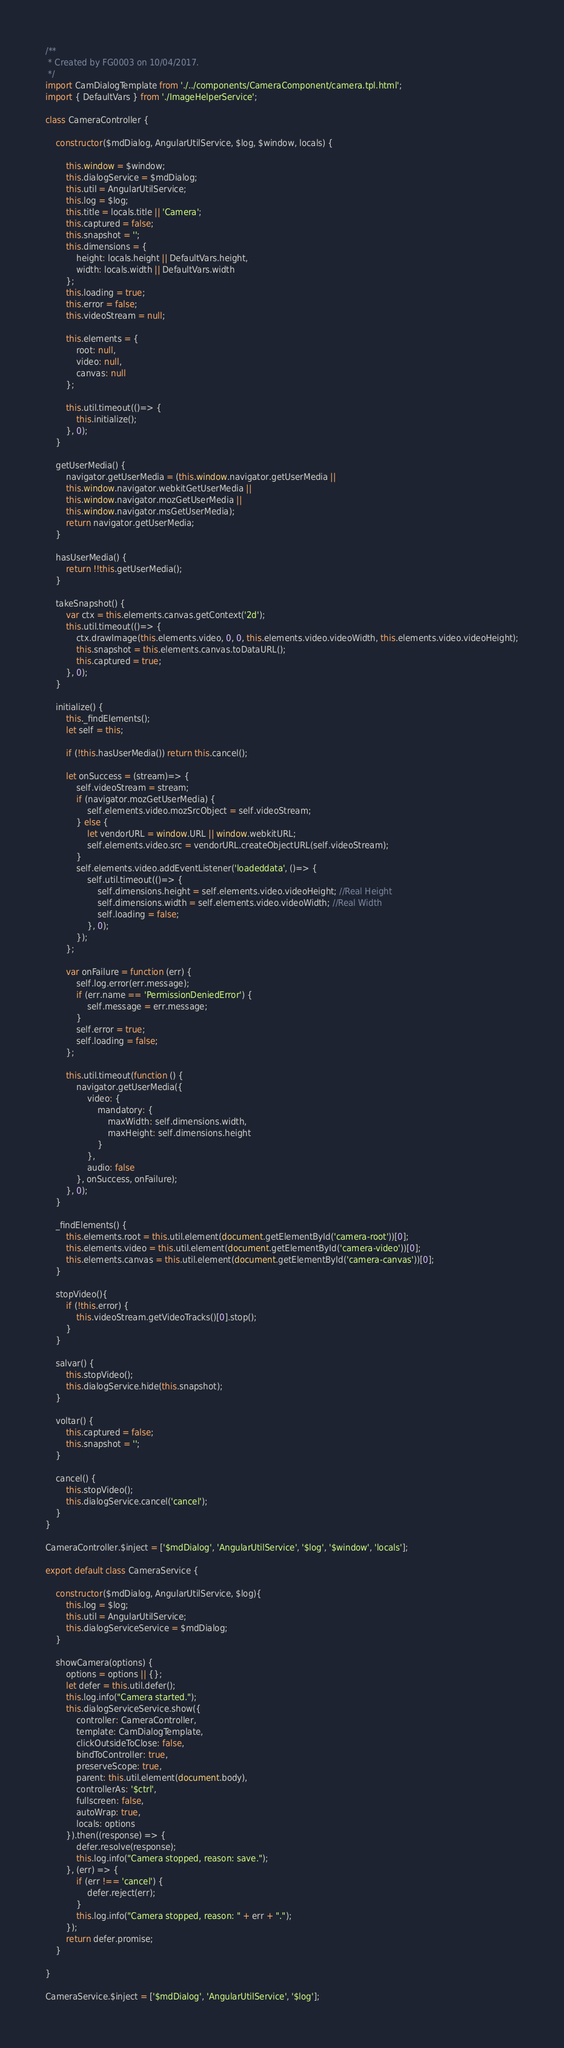Convert code to text. <code><loc_0><loc_0><loc_500><loc_500><_JavaScript_>/**
 * Created by FG0003 on 10/04/2017.
 */
import CamDialogTemplate from './../components/CameraComponent/camera.tpl.html';
import { DefaultVars } from './ImageHelperService';

class CameraController {

    constructor($mdDialog, AngularUtilService, $log, $window, locals) {

        this.window = $window;
        this.dialogService = $mdDialog;
        this.util = AngularUtilService;
        this.log = $log;
        this.title = locals.title || 'Camera';
        this.captured = false;
        this.snapshot = '';
        this.dimensions = {
            height: locals.height || DefaultVars.height,
            width: locals.width || DefaultVars.width
        };
        this.loading = true;
        this.error = false;
        this.videoStream = null;

        this.elements = {
            root: null,
            video: null,
            canvas: null
        };

        this.util.timeout(()=> {
            this.initialize();
        }, 0);
    }

    getUserMedia() {
        navigator.getUserMedia = (this.window.navigator.getUserMedia ||
        this.window.navigator.webkitGetUserMedia ||
        this.window.navigator.mozGetUserMedia ||
        this.window.navigator.msGetUserMedia);
        return navigator.getUserMedia;
    }

    hasUserMedia() {
        return !!this.getUserMedia();
    }

    takeSnapshot() {
        var ctx = this.elements.canvas.getContext('2d');
        this.util.timeout(()=> {
            ctx.drawImage(this.elements.video, 0, 0, this.elements.video.videoWidth, this.elements.video.videoHeight);
            this.snapshot = this.elements.canvas.toDataURL();
            this.captured = true;
        }, 0);
    }

    initialize() {
        this._findElements();
        let self = this;

        if (!this.hasUserMedia()) return this.cancel();

        let onSuccess = (stream)=> {
            self.videoStream = stream;
            if (navigator.mozGetUserMedia) {
                self.elements.video.mozSrcObject = self.videoStream;
            } else {
                let vendorURL = window.URL || window.webkitURL;
                self.elements.video.src = vendorURL.createObjectURL(self.videoStream);
            }
            self.elements.video.addEventListener('loadeddata', ()=> {
                self.util.timeout(()=> {
                    self.dimensions.height = self.elements.video.videoHeight; //Real Height
                    self.dimensions.width = self.elements.video.videoWidth; //Real Width
                    self.loading = false;
                }, 0);
            });
        };

        var onFailure = function (err) {
            self.log.error(err.message);
            if (err.name == 'PermissionDeniedError') {
                self.message = err.message;
            }
            self.error = true;
            self.loading = false;
        };

        this.util.timeout(function () {
            navigator.getUserMedia({
                video: {
                    mandatory: {
                        maxWidth: self.dimensions.width,
                        maxHeight: self.dimensions.height
                    }
                },
                audio: false
            }, onSuccess, onFailure);
        }, 0);
    }

    _findElements() {
        this.elements.root = this.util.element(document.getElementById('camera-root'))[0];
        this.elements.video = this.util.element(document.getElementById('camera-video'))[0];
        this.elements.canvas = this.util.element(document.getElementById('camera-canvas'))[0];
    }

    stopVideo(){
        if (!this.error) {
            this.videoStream.getVideoTracks()[0].stop();
        }
    }

    salvar() {
        this.stopVideo();
        this.dialogService.hide(this.snapshot);
    }

    voltar() {
        this.captured = false;
        this.snapshot = '';
    }

    cancel() {
        this.stopVideo();
        this.dialogService.cancel('cancel');
    }
}

CameraController.$inject = ['$mdDialog', 'AngularUtilService', '$log', '$window', 'locals'];

export default class CameraService {
    
    constructor($mdDialog, AngularUtilService, $log){
        this.log = $log;
        this.util = AngularUtilService;
        this.dialogServiceService = $mdDialog;
    }

    showCamera(options) {
        options = options || {};
        let defer = this.util.defer();
        this.log.info("Camera started.");
        this.dialogServiceService.show({
            controller: CameraController,
            template: CamDialogTemplate,
            clickOutsideToClose: false,
            bindToController: true,
            preserveScope: true,
            parent: this.util.element(document.body),
            controllerAs: '$ctrl',
            fullscreen: false,
            autoWrap: true,
            locals: options
        }).then((response) => {
            defer.resolve(response);
            this.log.info("Camera stopped, reason: save.");
        }, (err) => {
            if (err !== 'cancel') {
                defer.reject(err);
            }
            this.log.info("Camera stopped, reason: " + err + ".");
        });
        return defer.promise;
    }

}

CameraService.$inject = ['$mdDialog', 'AngularUtilService', '$log'];</code> 